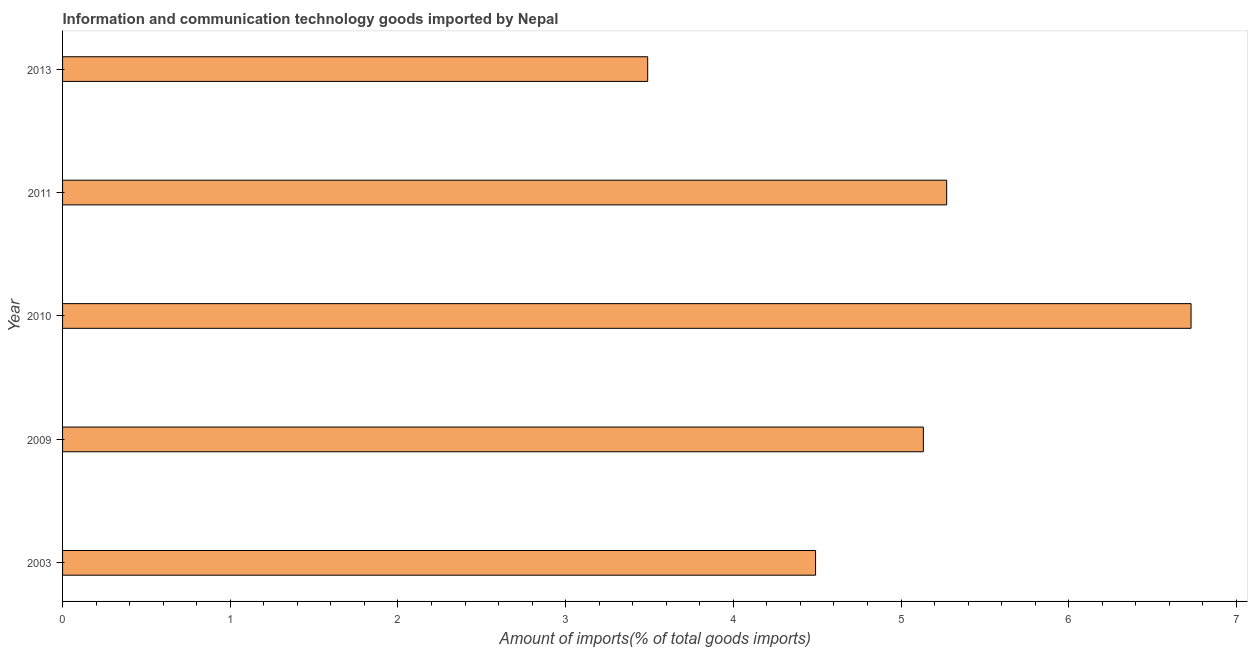Does the graph contain grids?
Your response must be concise. No. What is the title of the graph?
Provide a succinct answer. Information and communication technology goods imported by Nepal. What is the label or title of the X-axis?
Your answer should be very brief. Amount of imports(% of total goods imports). What is the amount of ict goods imports in 2011?
Your response must be concise. 5.27. Across all years, what is the maximum amount of ict goods imports?
Provide a succinct answer. 6.73. Across all years, what is the minimum amount of ict goods imports?
Your answer should be very brief. 3.49. In which year was the amount of ict goods imports maximum?
Provide a succinct answer. 2010. In which year was the amount of ict goods imports minimum?
Offer a very short reply. 2013. What is the sum of the amount of ict goods imports?
Your answer should be compact. 25.11. What is the difference between the amount of ict goods imports in 2010 and 2013?
Your answer should be compact. 3.24. What is the average amount of ict goods imports per year?
Ensure brevity in your answer.  5.02. What is the median amount of ict goods imports?
Your answer should be very brief. 5.13. In how many years, is the amount of ict goods imports greater than 3.2 %?
Provide a short and direct response. 5. What is the ratio of the amount of ict goods imports in 2003 to that in 2011?
Your answer should be compact. 0.85. Is the amount of ict goods imports in 2003 less than that in 2010?
Offer a very short reply. Yes. What is the difference between the highest and the second highest amount of ict goods imports?
Your response must be concise. 1.46. What is the difference between the highest and the lowest amount of ict goods imports?
Provide a succinct answer. 3.24. How many bars are there?
Your response must be concise. 5. What is the Amount of imports(% of total goods imports) in 2003?
Ensure brevity in your answer.  4.49. What is the Amount of imports(% of total goods imports) in 2009?
Your answer should be compact. 5.13. What is the Amount of imports(% of total goods imports) in 2010?
Your response must be concise. 6.73. What is the Amount of imports(% of total goods imports) in 2011?
Make the answer very short. 5.27. What is the Amount of imports(% of total goods imports) of 2013?
Your answer should be very brief. 3.49. What is the difference between the Amount of imports(% of total goods imports) in 2003 and 2009?
Provide a succinct answer. -0.64. What is the difference between the Amount of imports(% of total goods imports) in 2003 and 2010?
Keep it short and to the point. -2.24. What is the difference between the Amount of imports(% of total goods imports) in 2003 and 2011?
Keep it short and to the point. -0.78. What is the difference between the Amount of imports(% of total goods imports) in 2003 and 2013?
Keep it short and to the point. 1. What is the difference between the Amount of imports(% of total goods imports) in 2009 and 2010?
Offer a terse response. -1.6. What is the difference between the Amount of imports(% of total goods imports) in 2009 and 2011?
Give a very brief answer. -0.14. What is the difference between the Amount of imports(% of total goods imports) in 2009 and 2013?
Give a very brief answer. 1.64. What is the difference between the Amount of imports(% of total goods imports) in 2010 and 2011?
Provide a succinct answer. 1.46. What is the difference between the Amount of imports(% of total goods imports) in 2010 and 2013?
Your answer should be compact. 3.24. What is the difference between the Amount of imports(% of total goods imports) in 2011 and 2013?
Give a very brief answer. 1.78. What is the ratio of the Amount of imports(% of total goods imports) in 2003 to that in 2010?
Provide a succinct answer. 0.67. What is the ratio of the Amount of imports(% of total goods imports) in 2003 to that in 2011?
Offer a very short reply. 0.85. What is the ratio of the Amount of imports(% of total goods imports) in 2003 to that in 2013?
Offer a very short reply. 1.29. What is the ratio of the Amount of imports(% of total goods imports) in 2009 to that in 2010?
Offer a terse response. 0.76. What is the ratio of the Amount of imports(% of total goods imports) in 2009 to that in 2013?
Offer a terse response. 1.47. What is the ratio of the Amount of imports(% of total goods imports) in 2010 to that in 2011?
Your response must be concise. 1.28. What is the ratio of the Amount of imports(% of total goods imports) in 2010 to that in 2013?
Give a very brief answer. 1.93. What is the ratio of the Amount of imports(% of total goods imports) in 2011 to that in 2013?
Keep it short and to the point. 1.51. 